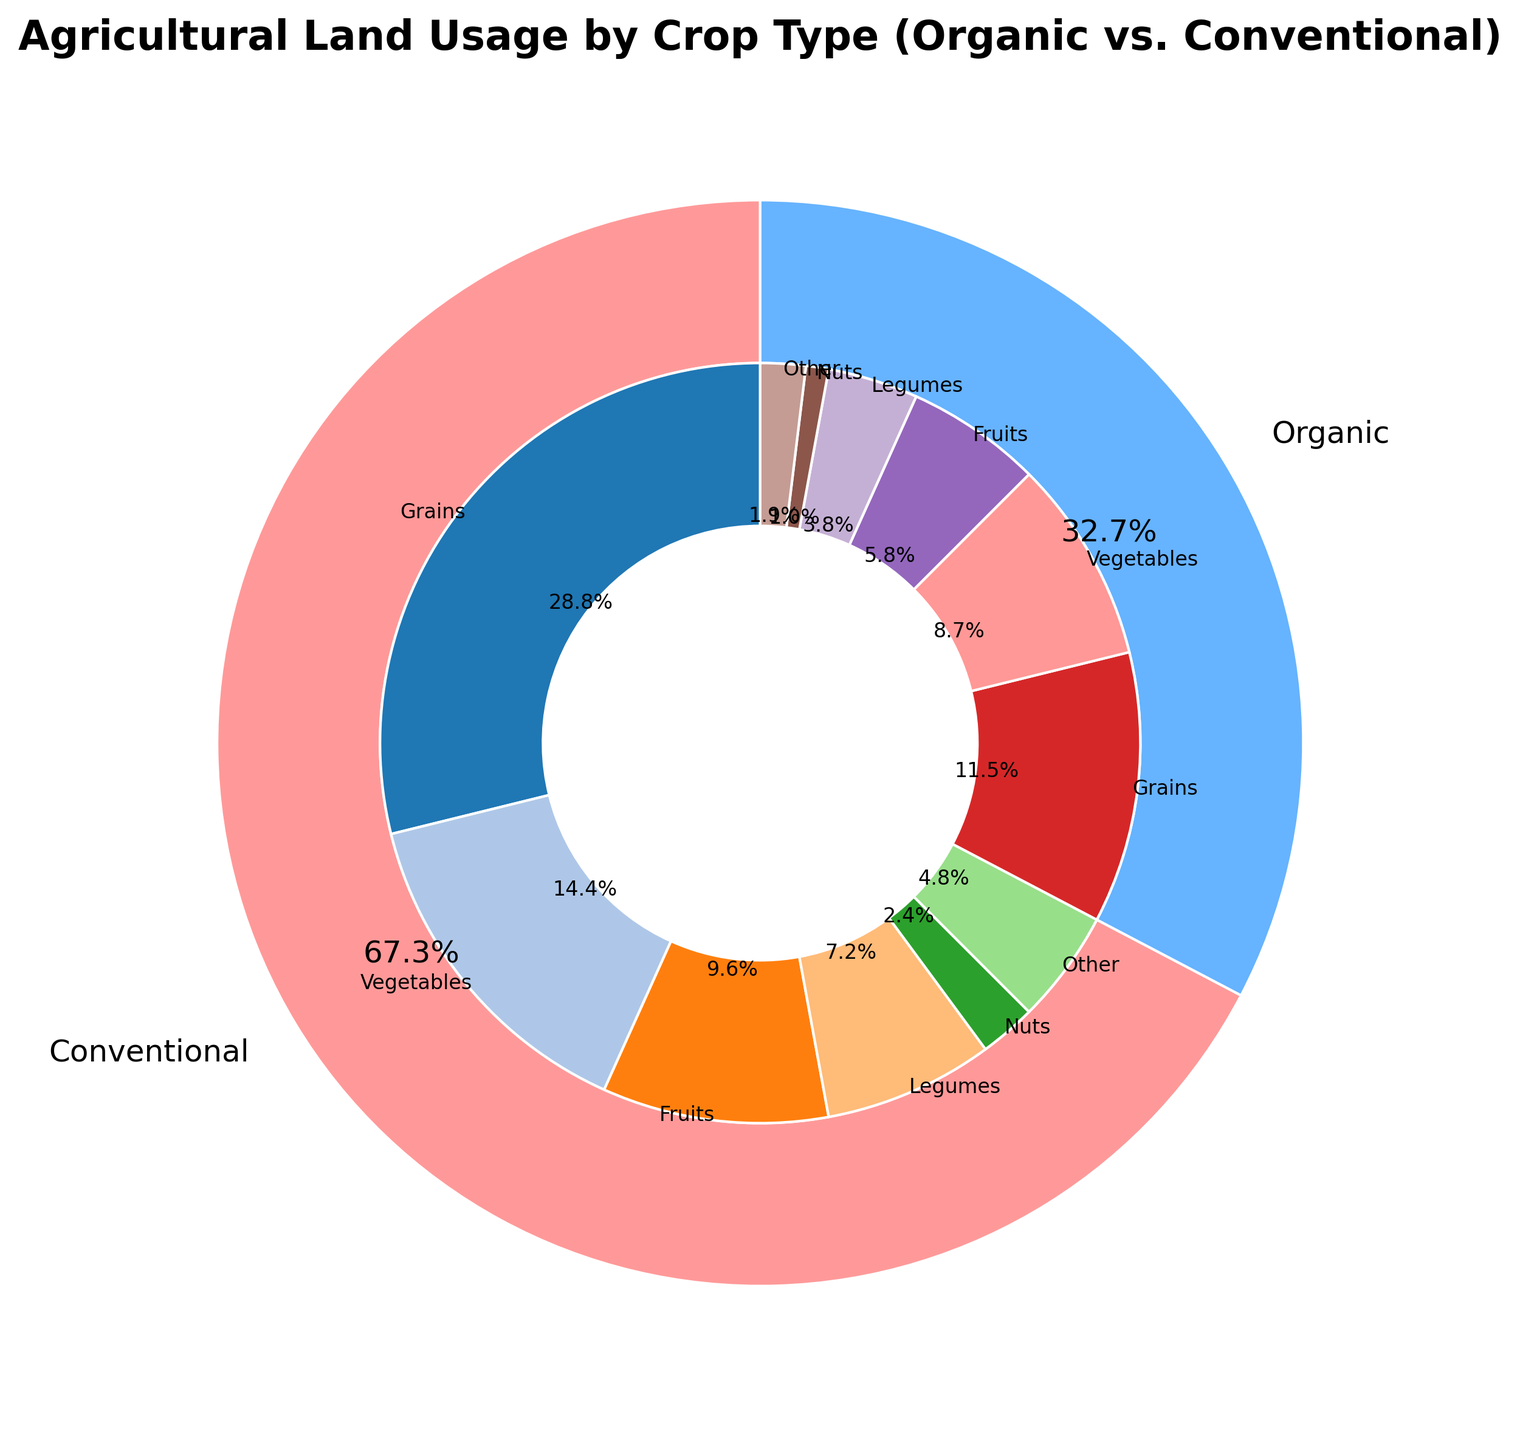Which category has the largest land usage? By looking at the outer ring of the pie chart, we can see that the "Conventional" category takes up the largest portion of the chart. This indicates that conventional farming methods use more land overall compared to organic methods.
Answer: Conventional How does the land usage for organic grains compare to conventional grains? To compare, we need to look at the inner ring for both grains sections. The size of the wedge for organic grains is smaller than that for conventional grains, indicating that conventional grains use more land.
Answer: Conventional grains use more land than organic grains What is the percentage difference between conventional and organic land usage for fruits? First, identify the percentages for fruits in both conventional and organic categories from the inner ring of the pie chart. Assume the labels provide this information. If conventional fruits use 10% and organic fruits use 6%, the difference in usage is calculated as 10% - 6% = 4%.
Answer: 4% What is the total land usage for legumes in both conventional and organic categories? To find the total, sum the amounts for legumes in both categories. Conventional legumes use 75 units and organic legumes use 40 units. So, 75 + 40 = 115 units.
Answer: 115 units Which category has a higher ratio of vegetable land usage, organic or conventional? From the inner ring, compare the wedge sizes for vegetables in both organic and conventional categories. The organic portion is smaller than the conventional one, indicating organic has a lower ratio.
Answer: Conventional Are nuts more commonly grown in conventional or organic farming? By looking at the wedges in the inner ring, nuts in the conventional section appear larger than in the organic section, indicating more land usage in conventional farming.
Answer: Conventional Does the amount of "Other" crops differ significantly between conventional and organic farming? By comparing the inner ring sizes, conventional "Other" section is larger than the organic one. To see if it's significant, compare the values (50 vs 20), which is more than double in conventional.
Answer: Yes What is the combined percentage of land usage for organic and conventional vegetables? Sum the percentages of the inner wedges for vegetables in both categories. If conventional vegetables are 15% and organic vegetables are 9%, the combined percentage is 15% + 9% = 24%.
Answer: 24% What crop type has the smallest land usage in organic farming? In the inner ring for the organic category, the wedge for nuts is the smallest, showing that nuts have the least land usage in organic farming.
Answer: Nuts How does the percentage of land used for grains in conventional farming compare to the total land used for vegetables in organic farming? From the inner ring, assign the respective percentages to each category. Suppose grains in conventional farming use 30% of the land, and vegetables in organic farming use 9%, then grains in conventional farming use a much larger percentage.
Answer: Conventional grains use more land than organic vegetables 